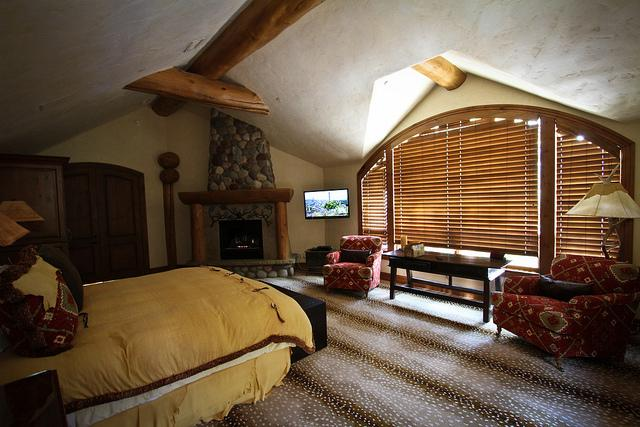What is the rectangular image in the corner of the room?

Choices:
A) poster
B) tablet
C) television
D) painting television 